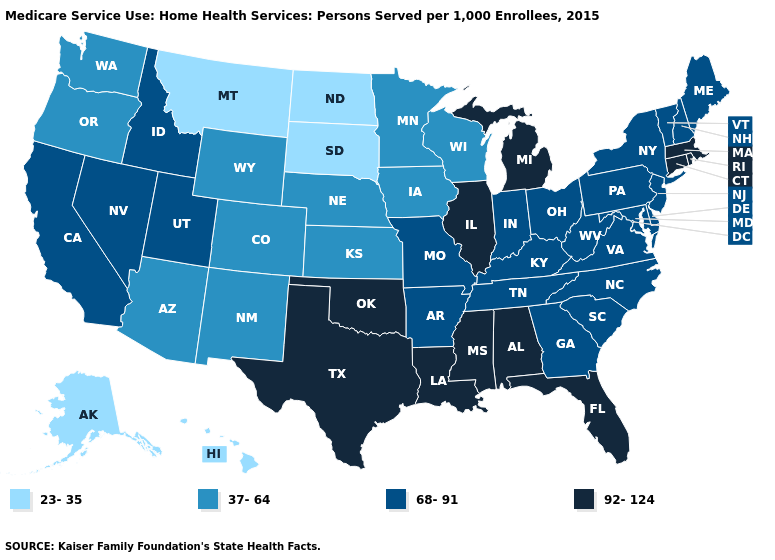What is the value of Michigan?
Write a very short answer. 92-124. Name the states that have a value in the range 92-124?
Keep it brief. Alabama, Connecticut, Florida, Illinois, Louisiana, Massachusetts, Michigan, Mississippi, Oklahoma, Rhode Island, Texas. What is the value of Oklahoma?
Answer briefly. 92-124. Does the map have missing data?
Answer briefly. No. What is the value of Minnesota?
Quick response, please. 37-64. Name the states that have a value in the range 37-64?
Short answer required. Arizona, Colorado, Iowa, Kansas, Minnesota, Nebraska, New Mexico, Oregon, Washington, Wisconsin, Wyoming. Does Tennessee have the lowest value in the USA?
Give a very brief answer. No. Among the states that border Tennessee , does Mississippi have the highest value?
Be succinct. Yes. What is the value of Kansas?
Write a very short answer. 37-64. What is the value of New Mexico?
Keep it brief. 37-64. Which states have the lowest value in the USA?
Keep it brief. Alaska, Hawaii, Montana, North Dakota, South Dakota. Does the map have missing data?
Be succinct. No. What is the value of Nevada?
Short answer required. 68-91. What is the highest value in the USA?
Concise answer only. 92-124. Among the states that border Kentucky , which have the highest value?
Short answer required. Illinois. 